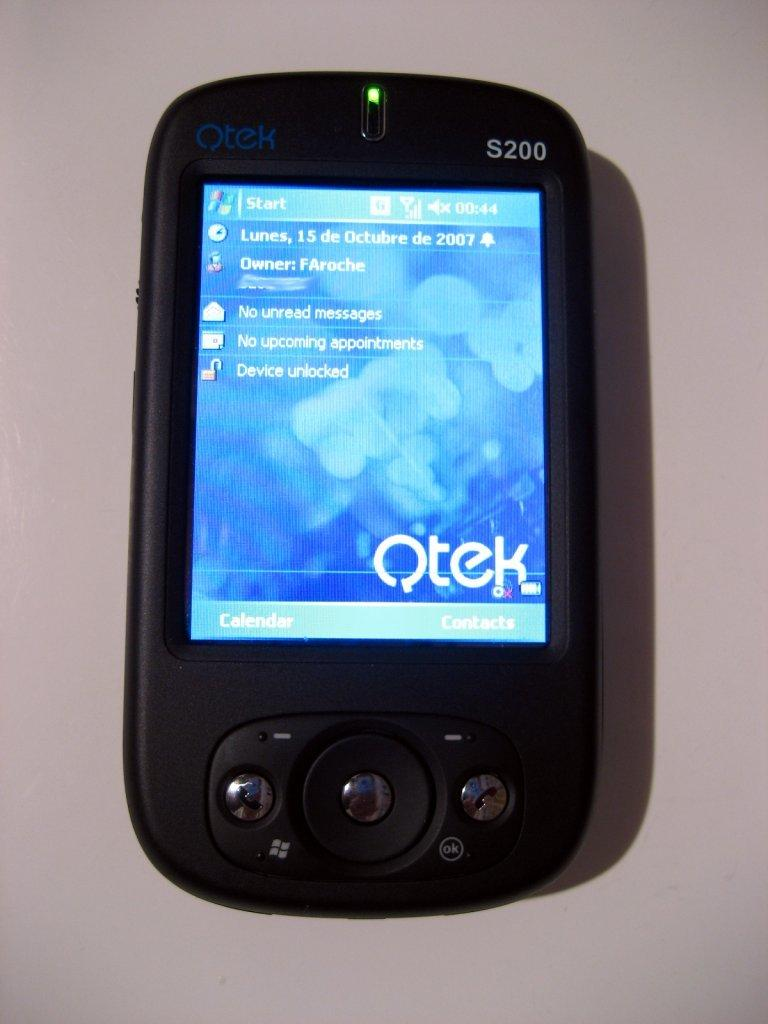<image>
Share a concise interpretation of the image provided. A Qtek phone shows the year of 2007 on the top right. 